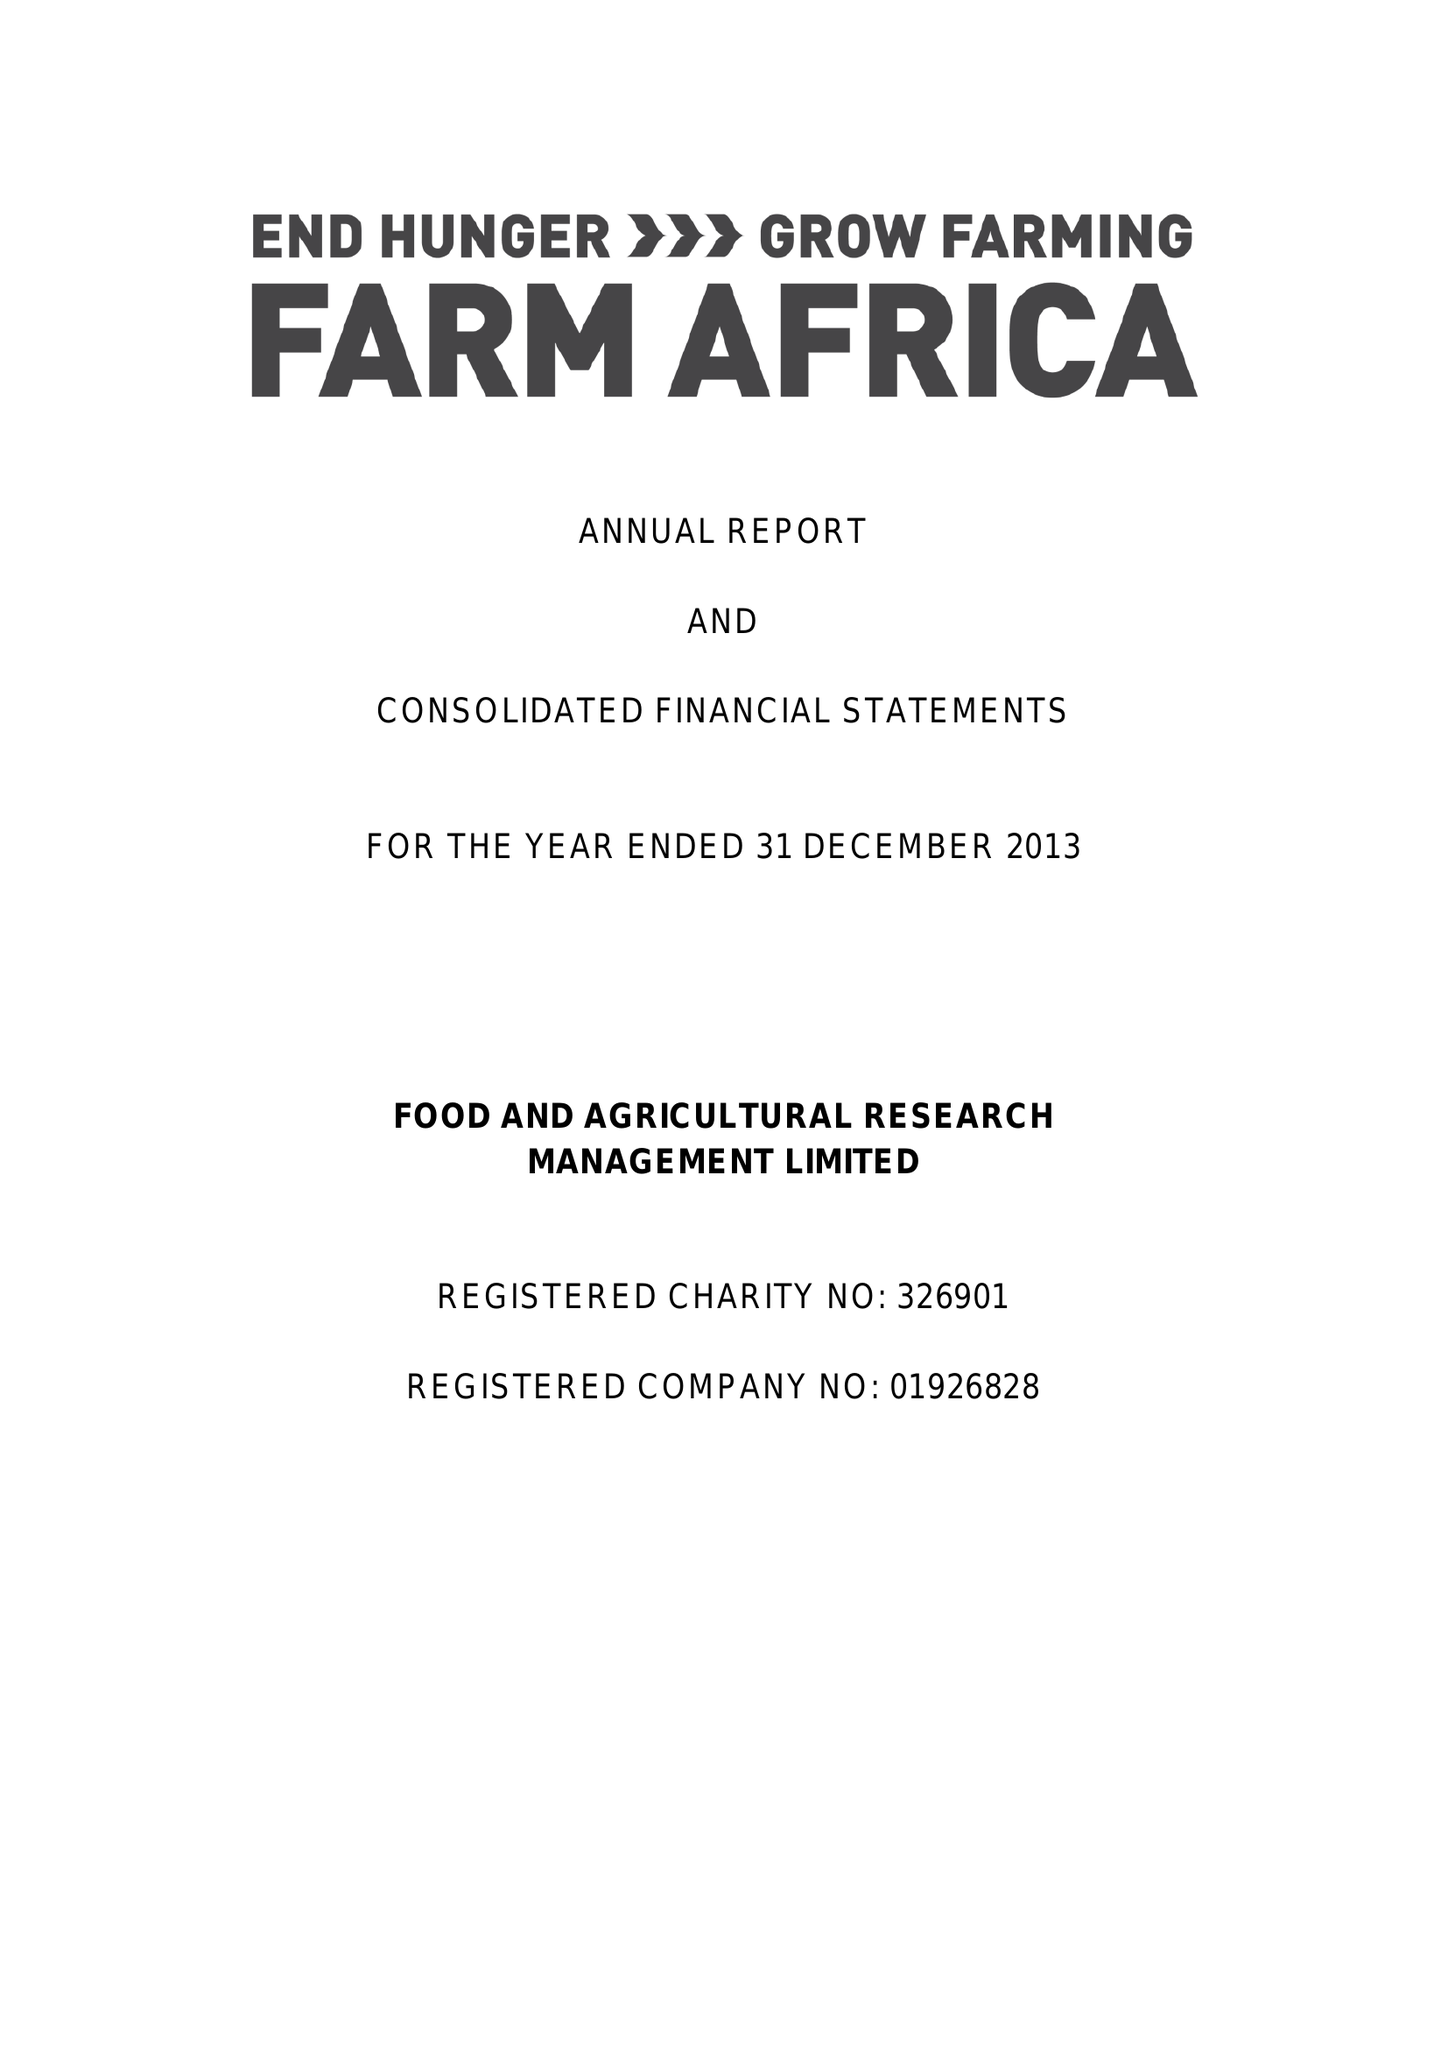What is the value for the address__street_line?
Answer the question using a single word or phrase. 140 LONDON WALL 